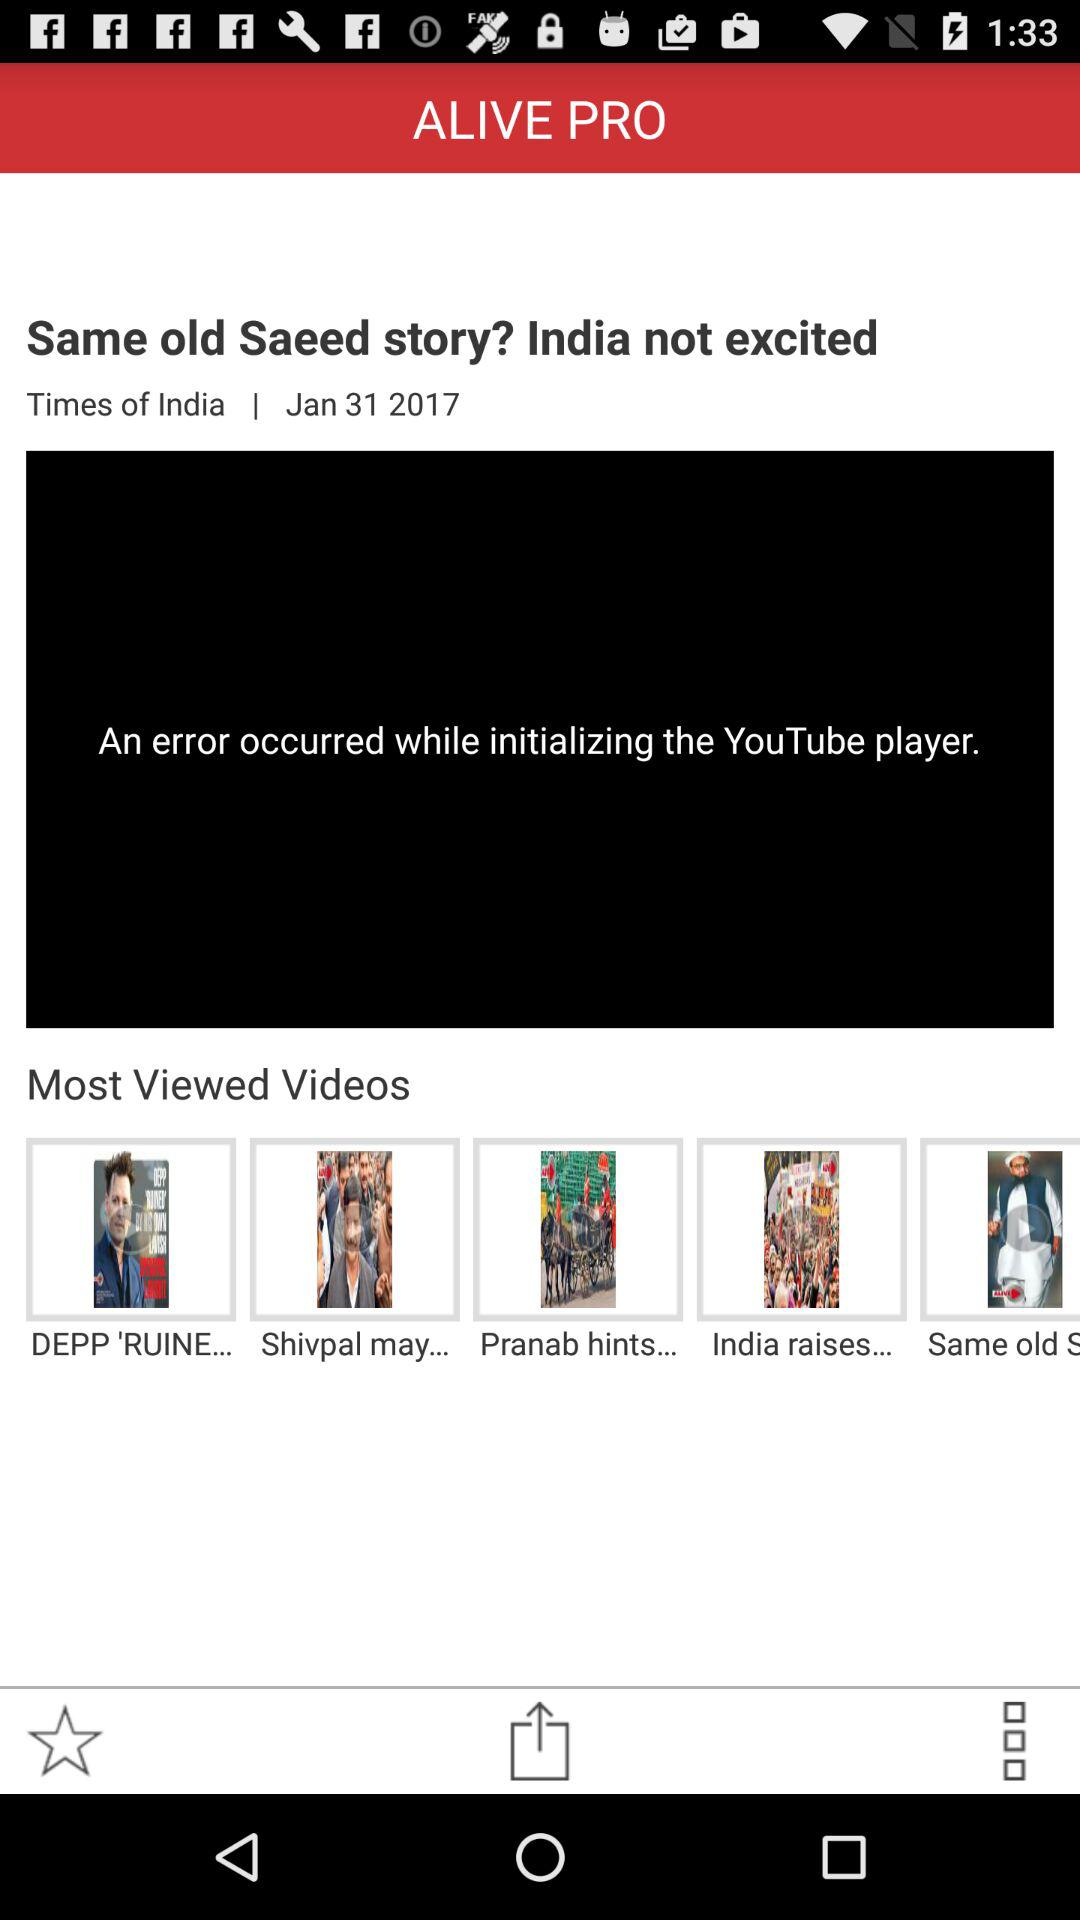What is the application name? The application name is "ALIVE PRO". 